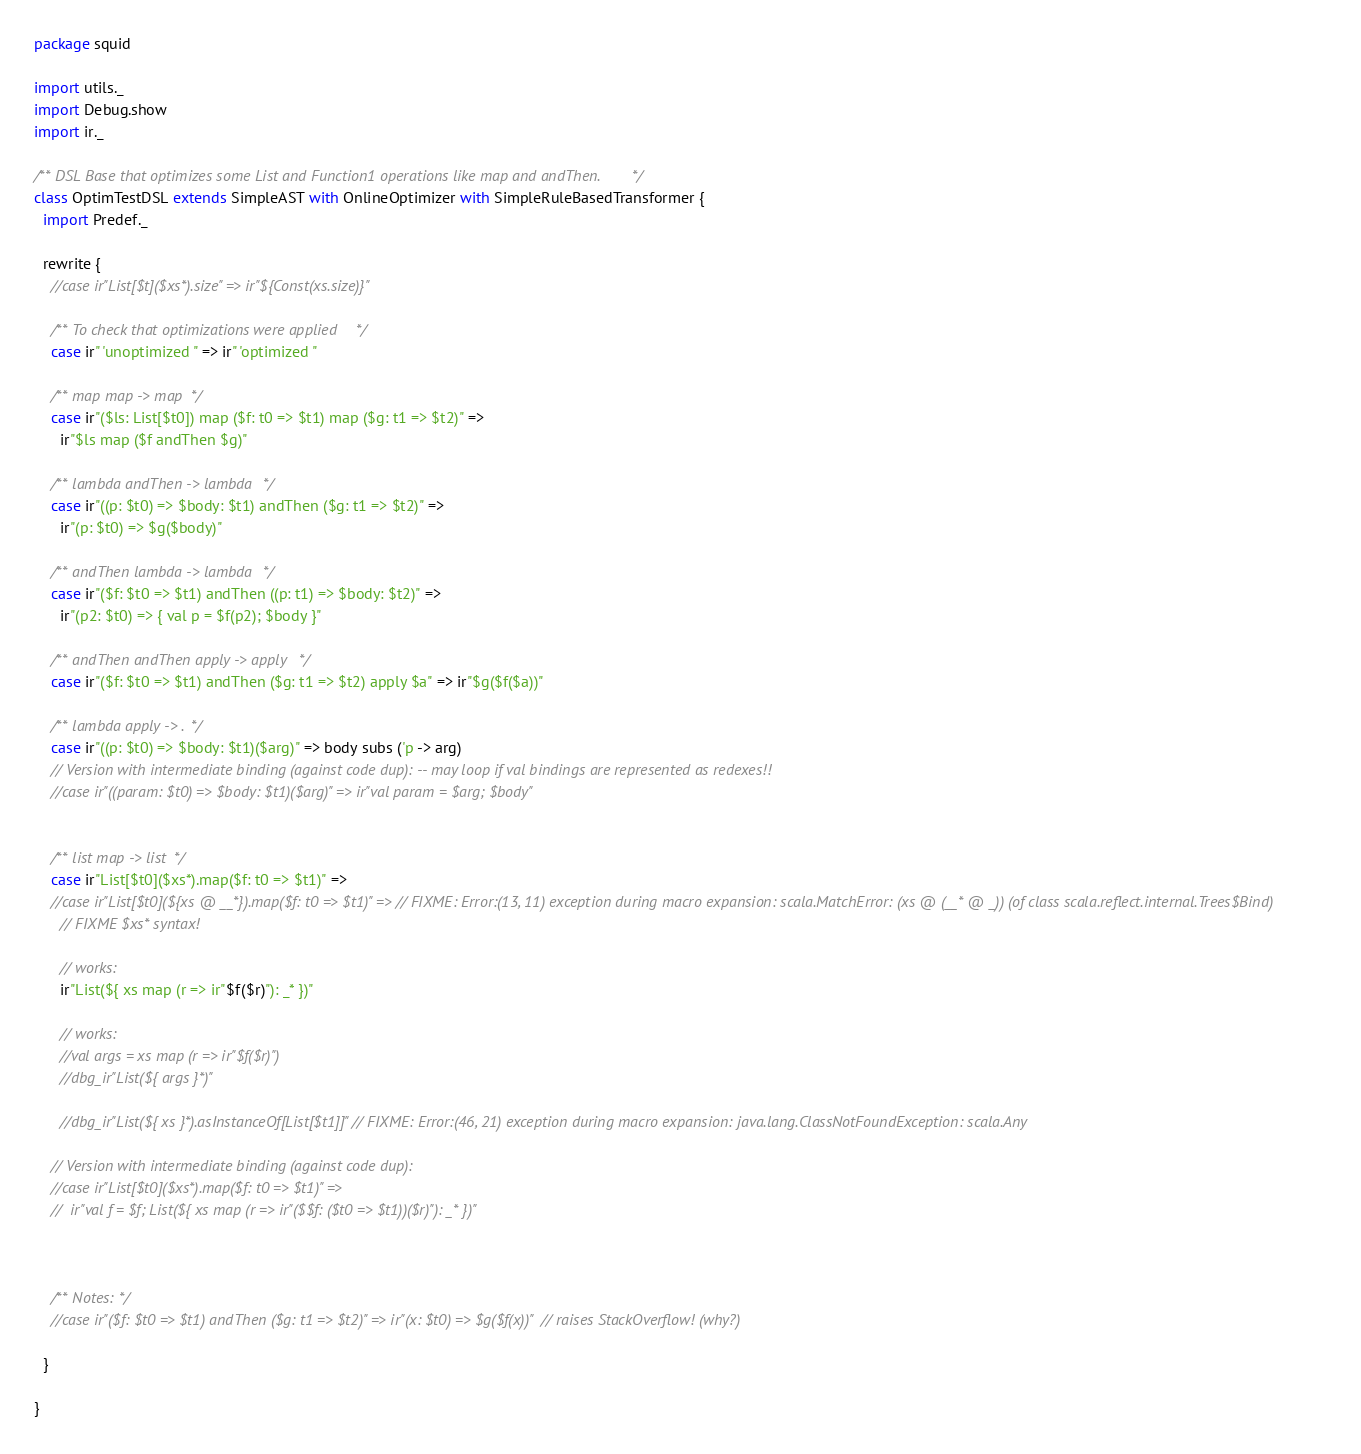Convert code to text. <code><loc_0><loc_0><loc_500><loc_500><_Scala_>package squid

import utils._
import Debug.show
import ir._

/** DSL Base that optimizes some List and Function1 operations like map and andThen. */
class OptimTestDSL extends SimpleAST with OnlineOptimizer with SimpleRuleBasedTransformer {
  import Predef._
  
  rewrite {
    //case ir"List[$t]($xs*).size" => ir"${Const(xs.size)}"
    
    /** To check that optimizations were applied */
    case ir" 'unoptimized " => ir" 'optimized "
      
    /** map map -> map */
    case ir"($ls: List[$t0]) map ($f: t0 => $t1) map ($g: t1 => $t2)" =>
      ir"$ls map ($f andThen $g)"
      
    /** lambda andThen -> lambda */
    case ir"((p: $t0) => $body: $t1) andThen ($g: t1 => $t2)" =>
      ir"(p: $t0) => $g($body)"
    
    /** andThen lambda -> lambda */
    case ir"($f: $t0 => $t1) andThen ((p: t1) => $body: $t2)" =>
      ir"(p2: $t0) => { val p = $f(p2); $body }"
      
    /** andThen andThen apply -> apply */
    case ir"($f: $t0 => $t1) andThen ($g: t1 => $t2) apply $a" => ir"$g($f($a))"
      
    /** lambda apply -> . */
    case ir"((p: $t0) => $body: $t1)($arg)" => body subs ('p -> arg)
    // Version with intermediate binding (against code dup): -- may loop if val bindings are represented as redexes!!
    //case ir"((param: $t0) => $body: $t1)($arg)" => ir"val param = $arg; $body"
      
      
    /** list map -> list */
    case ir"List[$t0]($xs*).map($f: t0 => $t1)" =>
    //case ir"List[$t0](${xs @ __*}).map($f: t0 => $t1)" => // FIXME: Error:(13, 11) exception during macro expansion: scala.MatchError: (xs @ (__* @ _)) (of class scala.reflect.internal.Trees$Bind)
      // FIXME $xs* syntax!
      
      // works:
      ir"List(${ xs map (r => ir"$f($r)"): _* })"
      
      // works:
      //val args = xs map (r => ir"$f($r)")
      //dbg_ir"List(${ args }*)"
      
      //dbg_ir"List(${ xs }*).asInstanceOf[List[$t1]]" // FIXME: Error:(46, 21) exception during macro expansion: java.lang.ClassNotFoundException: scala.Any 
      
    // Version with intermediate binding (against code dup):
    //case ir"List[$t0]($xs*).map($f: t0 => $t1)" =>
    //  ir"val f = $f; List(${ xs map (r => ir"($$f: ($t0 => $t1))($r)"): _* })"
    
    
    
    /** Notes: */
    //case ir"($f: $t0 => $t1) andThen ($g: t1 => $t2)" => ir"(x: $t0) => $g($f(x))"  // raises StackOverflow! (why?)
    
  }
  
}

</code> 